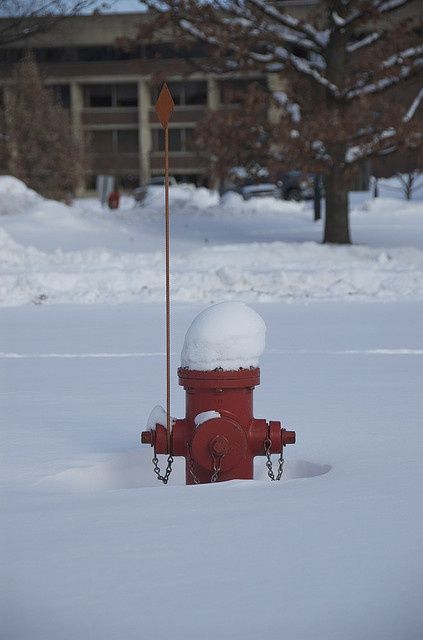Describe the objects in this image and their specific colors. I can see fire hydrant in gray, maroon, darkgray, and lightgray tones, truck in gray, black, and darkblue tones, truck in gray and black tones, and people in gray, maroon, black, and brown tones in this image. 